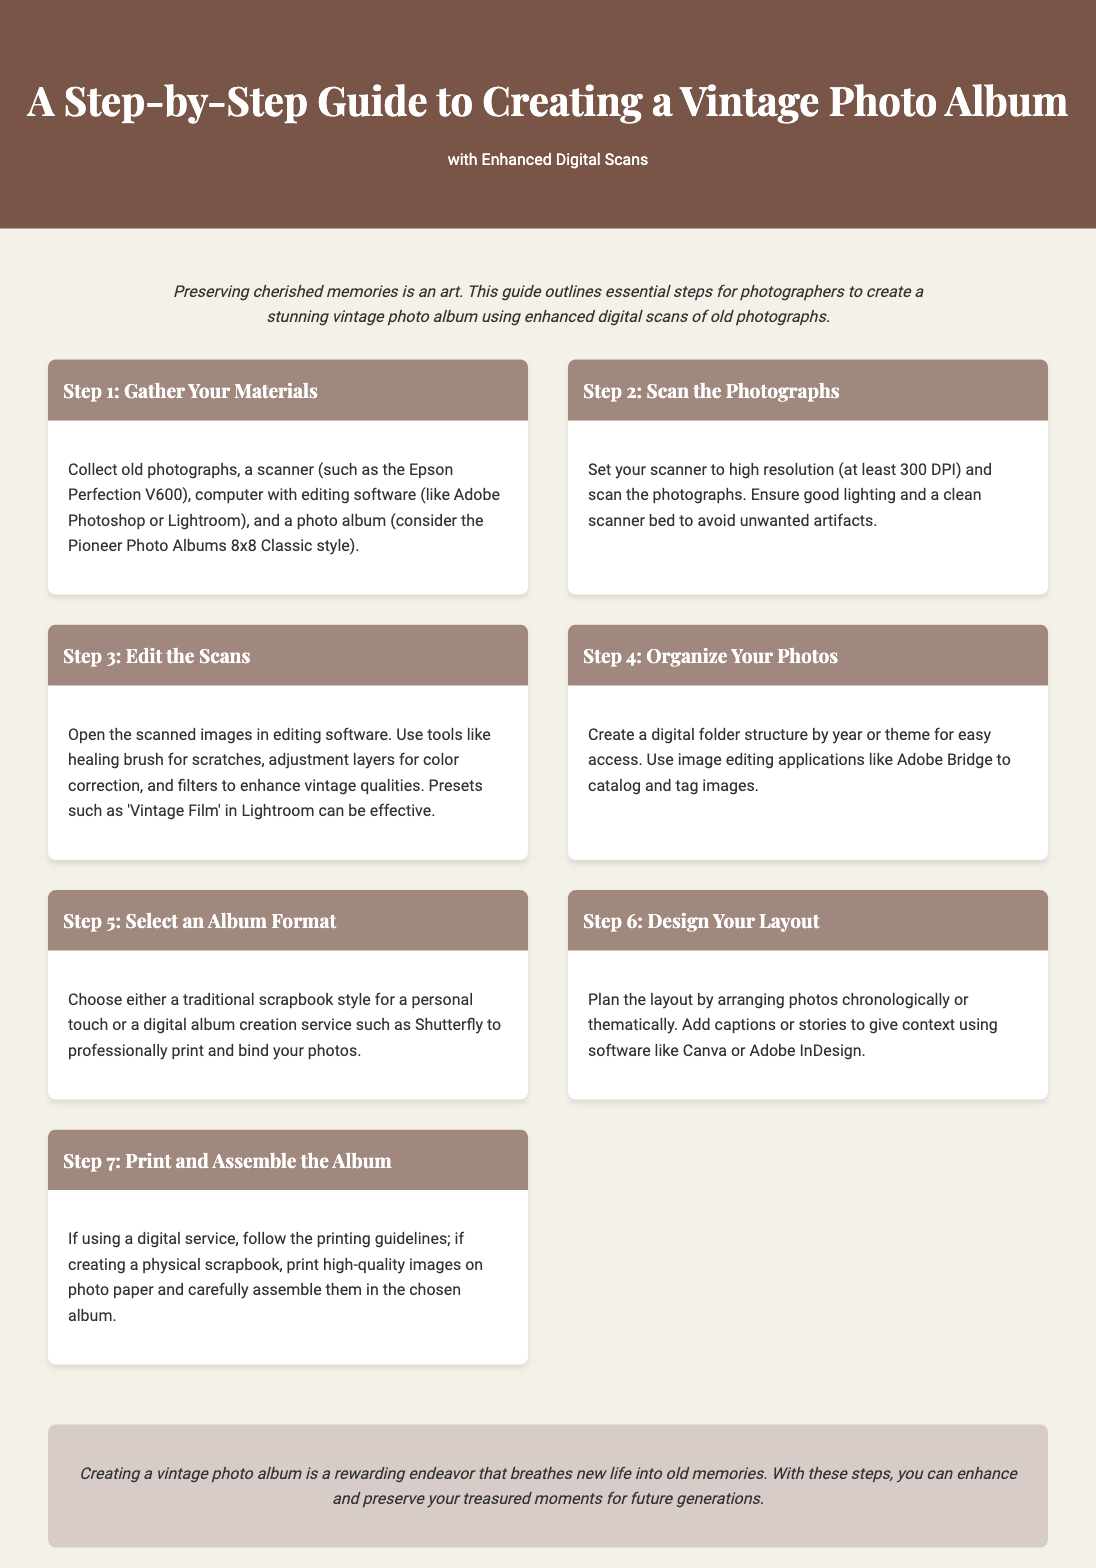What is the title of the guide? The title of the guide appears at the top of the document and is stated clearly as "A Step-by-Step Guide to Creating a Vintage Photo Album."
Answer: A Step-by-Step Guide to Creating a Vintage Photo Album What is the recommended scanner model? The document mentions "Epson Perfection V600" as a suggested scanner model for digitizing photographs.
Answer: Epson Perfection V600 What resolution should the photographs be scanned at? The guide specifies a scanning resolution of "at least 300 DPI" for optimal results.
Answer: at least 300 DPI What are two software options listed for editing scans? The document lists "Adobe Photoshop" and "Lightroom" as software options for photo editing.
Answer: Adobe Photoshop, Lightroom What style of photo album is suggested in Step 1? The guide refers to the "Pioneer Photo Albums 8x8 Classic style" as a recommended photo album.
Answer: Pioneer Photo Albums 8x8 Classic style What is the focus of Step 5 in the guide? Step 5 emphasizes choosing an "album format," whether traditional or digital service for printing.
Answer: album format What should be added to photos in Step 6? The document suggests adding "captions or stories" to provide context to the photos in the album.
Answer: captions or stories What is the overall goal stated in the conclusion? The conclusion mentions that the goal of creating a vintage photo album is to "breathe new life into old memories."
Answer: breathe new life into old memories What should be used for high-quality prints? The guide advises printing photos on "photo paper" for the best quality in the album assembly process.
Answer: photo paper 